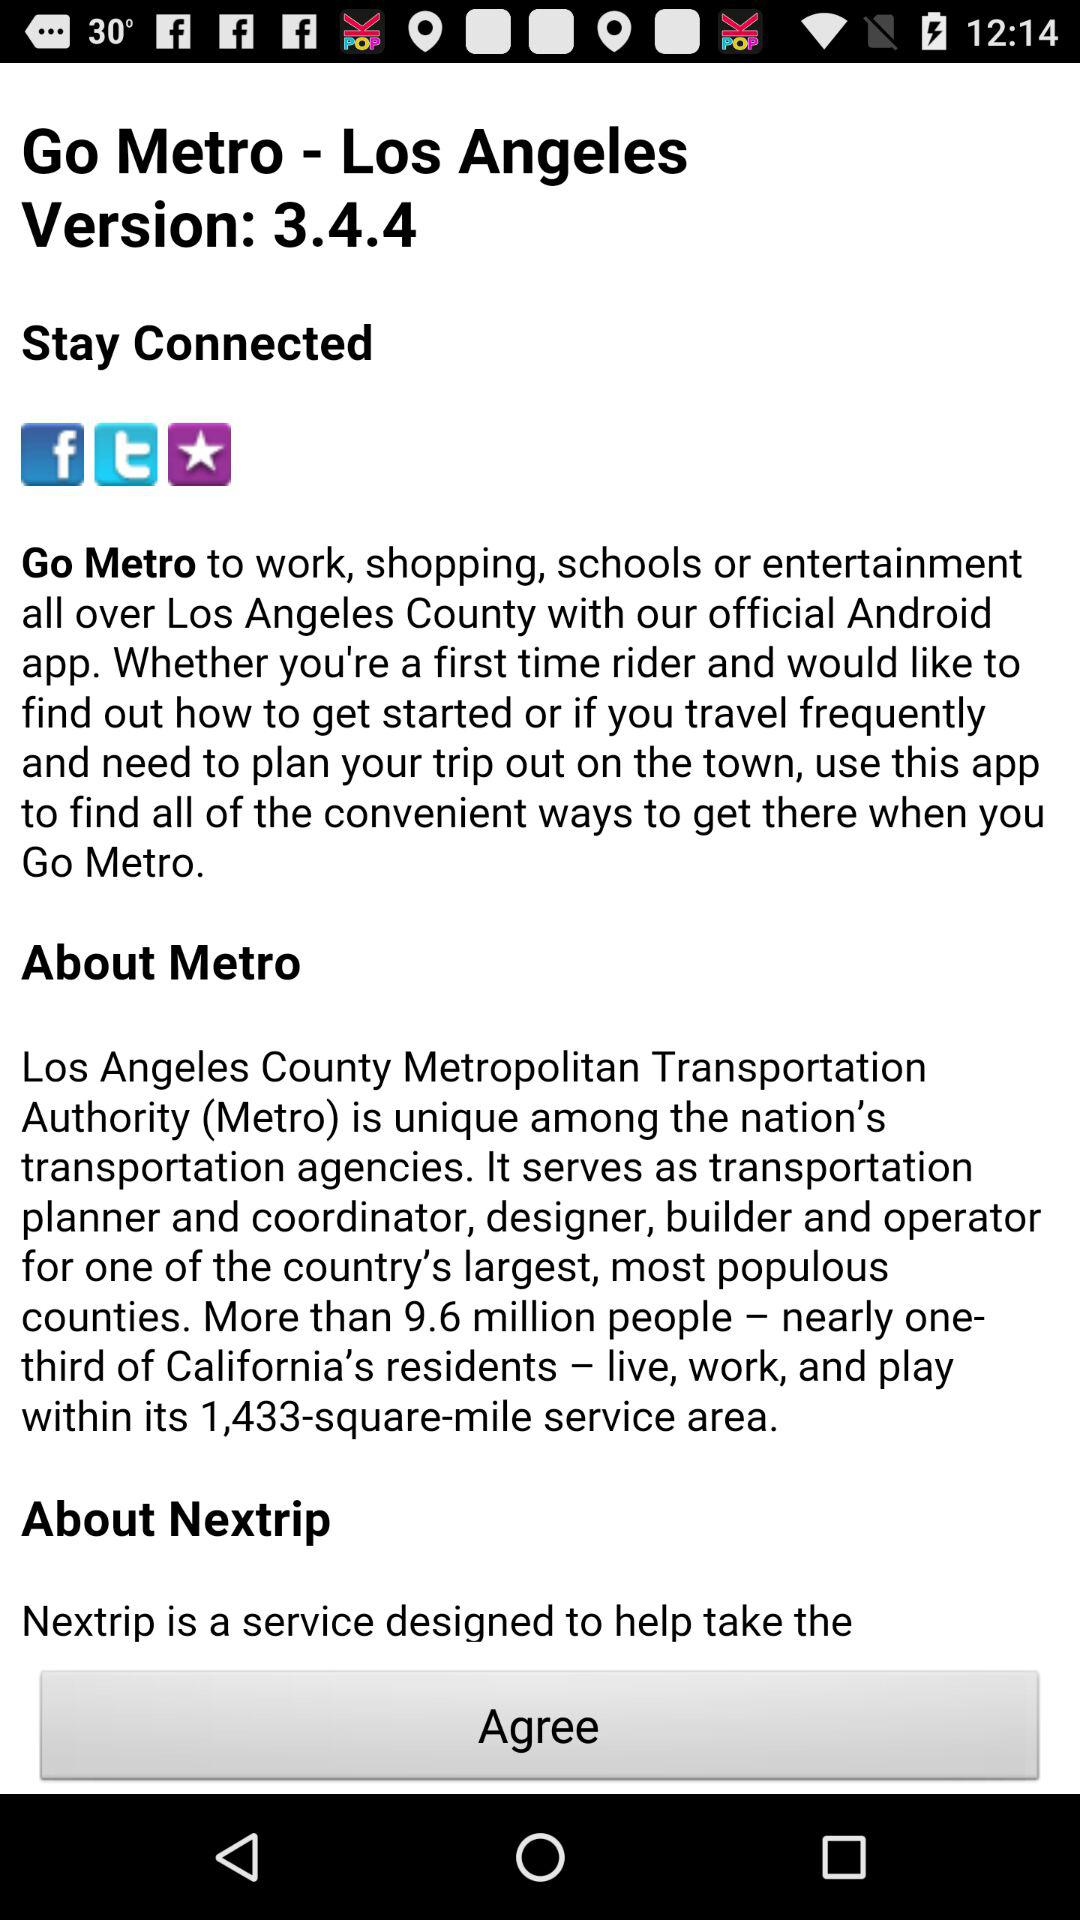What is the version of "Go Metro"? The version is 3.4.4. 